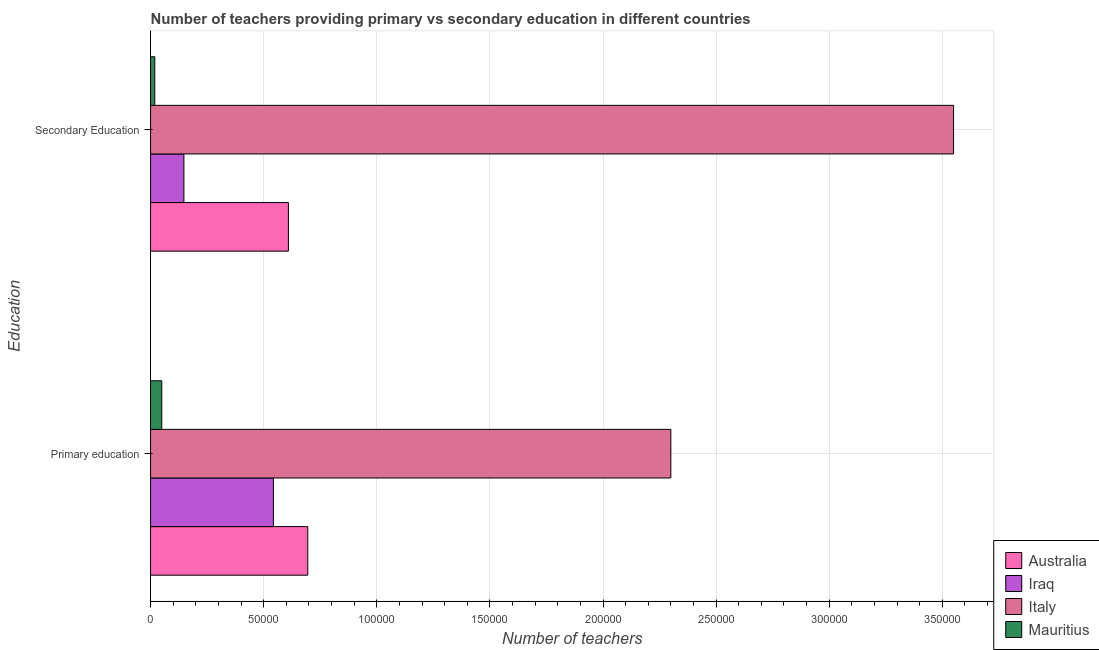How many different coloured bars are there?
Keep it short and to the point. 4. Are the number of bars per tick equal to the number of legend labels?
Your response must be concise. Yes. Are the number of bars on each tick of the Y-axis equal?
Offer a terse response. Yes. How many bars are there on the 2nd tick from the top?
Your answer should be compact. 4. How many bars are there on the 2nd tick from the bottom?
Your answer should be very brief. 4. What is the label of the 2nd group of bars from the top?
Offer a terse response. Primary education. What is the number of primary teachers in Australia?
Your answer should be compact. 6.95e+04. Across all countries, what is the maximum number of primary teachers?
Offer a very short reply. 2.30e+05. Across all countries, what is the minimum number of primary teachers?
Give a very brief answer. 4952. In which country was the number of primary teachers maximum?
Offer a very short reply. Italy. In which country was the number of secondary teachers minimum?
Offer a very short reply. Mauritius. What is the total number of secondary teachers in the graph?
Provide a short and direct response. 4.33e+05. What is the difference between the number of secondary teachers in Iraq and that in Italy?
Your response must be concise. -3.40e+05. What is the difference between the number of primary teachers in Australia and the number of secondary teachers in Italy?
Your answer should be compact. -2.85e+05. What is the average number of secondary teachers per country?
Make the answer very short. 1.08e+05. What is the difference between the number of primary teachers and number of secondary teachers in Italy?
Offer a very short reply. -1.25e+05. In how many countries, is the number of primary teachers greater than 280000 ?
Your response must be concise. 0. What is the ratio of the number of secondary teachers in Mauritius to that in Australia?
Provide a succinct answer. 0.03. Is the number of primary teachers in Italy less than that in Iraq?
Provide a short and direct response. No. How many bars are there?
Offer a very short reply. 8. Are all the bars in the graph horizontal?
Make the answer very short. Yes. How many countries are there in the graph?
Offer a terse response. 4. Are the values on the major ticks of X-axis written in scientific E-notation?
Provide a succinct answer. No. Does the graph contain any zero values?
Offer a terse response. No. Where does the legend appear in the graph?
Keep it short and to the point. Bottom right. How many legend labels are there?
Your answer should be compact. 4. How are the legend labels stacked?
Give a very brief answer. Vertical. What is the title of the graph?
Offer a terse response. Number of teachers providing primary vs secondary education in different countries. What is the label or title of the X-axis?
Provide a short and direct response. Number of teachers. What is the label or title of the Y-axis?
Provide a succinct answer. Education. What is the Number of teachers in Australia in Primary education?
Provide a short and direct response. 6.95e+04. What is the Number of teachers in Iraq in Primary education?
Your answer should be compact. 5.43e+04. What is the Number of teachers in Italy in Primary education?
Your answer should be compact. 2.30e+05. What is the Number of teachers in Mauritius in Primary education?
Provide a succinct answer. 4952. What is the Number of teachers in Australia in Secondary Education?
Provide a succinct answer. 6.09e+04. What is the Number of teachers in Iraq in Secondary Education?
Your response must be concise. 1.47e+04. What is the Number of teachers of Italy in Secondary Education?
Ensure brevity in your answer.  3.55e+05. What is the Number of teachers of Mauritius in Secondary Education?
Offer a terse response. 1856. Across all Education, what is the maximum Number of teachers of Australia?
Offer a very short reply. 6.95e+04. Across all Education, what is the maximum Number of teachers in Iraq?
Make the answer very short. 5.43e+04. Across all Education, what is the maximum Number of teachers of Italy?
Offer a terse response. 3.55e+05. Across all Education, what is the maximum Number of teachers of Mauritius?
Make the answer very short. 4952. Across all Education, what is the minimum Number of teachers in Australia?
Make the answer very short. 6.09e+04. Across all Education, what is the minimum Number of teachers of Iraq?
Your answer should be very brief. 1.47e+04. Across all Education, what is the minimum Number of teachers in Italy?
Offer a terse response. 2.30e+05. Across all Education, what is the minimum Number of teachers of Mauritius?
Provide a short and direct response. 1856. What is the total Number of teachers in Australia in the graph?
Your response must be concise. 1.30e+05. What is the total Number of teachers of Iraq in the graph?
Your response must be concise. 6.90e+04. What is the total Number of teachers of Italy in the graph?
Provide a succinct answer. 5.85e+05. What is the total Number of teachers of Mauritius in the graph?
Make the answer very short. 6808. What is the difference between the Number of teachers of Australia in Primary education and that in Secondary Education?
Give a very brief answer. 8561. What is the difference between the Number of teachers of Iraq in Primary education and that in Secondary Education?
Offer a terse response. 3.96e+04. What is the difference between the Number of teachers in Italy in Primary education and that in Secondary Education?
Provide a short and direct response. -1.25e+05. What is the difference between the Number of teachers in Mauritius in Primary education and that in Secondary Education?
Your answer should be very brief. 3096. What is the difference between the Number of teachers of Australia in Primary education and the Number of teachers of Iraq in Secondary Education?
Your response must be concise. 5.48e+04. What is the difference between the Number of teachers of Australia in Primary education and the Number of teachers of Italy in Secondary Education?
Offer a terse response. -2.85e+05. What is the difference between the Number of teachers of Australia in Primary education and the Number of teachers of Mauritius in Secondary Education?
Your answer should be very brief. 6.76e+04. What is the difference between the Number of teachers in Iraq in Primary education and the Number of teachers in Italy in Secondary Education?
Offer a terse response. -3.01e+05. What is the difference between the Number of teachers in Iraq in Primary education and the Number of teachers in Mauritius in Secondary Education?
Provide a succinct answer. 5.24e+04. What is the difference between the Number of teachers of Italy in Primary education and the Number of teachers of Mauritius in Secondary Education?
Make the answer very short. 2.28e+05. What is the average Number of teachers in Australia per Education?
Give a very brief answer. 6.52e+04. What is the average Number of teachers of Iraq per Education?
Your answer should be compact. 3.45e+04. What is the average Number of teachers of Italy per Education?
Provide a short and direct response. 2.92e+05. What is the average Number of teachers of Mauritius per Education?
Provide a succinct answer. 3404. What is the difference between the Number of teachers in Australia and Number of teachers in Iraq in Primary education?
Provide a succinct answer. 1.52e+04. What is the difference between the Number of teachers of Australia and Number of teachers of Italy in Primary education?
Ensure brevity in your answer.  -1.60e+05. What is the difference between the Number of teachers in Australia and Number of teachers in Mauritius in Primary education?
Offer a terse response. 6.45e+04. What is the difference between the Number of teachers in Iraq and Number of teachers in Italy in Primary education?
Provide a short and direct response. -1.76e+05. What is the difference between the Number of teachers of Iraq and Number of teachers of Mauritius in Primary education?
Keep it short and to the point. 4.94e+04. What is the difference between the Number of teachers in Italy and Number of teachers in Mauritius in Primary education?
Provide a succinct answer. 2.25e+05. What is the difference between the Number of teachers in Australia and Number of teachers in Iraq in Secondary Education?
Ensure brevity in your answer.  4.62e+04. What is the difference between the Number of teachers in Australia and Number of teachers in Italy in Secondary Education?
Your answer should be compact. -2.94e+05. What is the difference between the Number of teachers of Australia and Number of teachers of Mauritius in Secondary Education?
Your response must be concise. 5.91e+04. What is the difference between the Number of teachers of Iraq and Number of teachers of Italy in Secondary Education?
Make the answer very short. -3.40e+05. What is the difference between the Number of teachers of Iraq and Number of teachers of Mauritius in Secondary Education?
Offer a very short reply. 1.29e+04. What is the difference between the Number of teachers in Italy and Number of teachers in Mauritius in Secondary Education?
Your answer should be compact. 3.53e+05. What is the ratio of the Number of teachers in Australia in Primary education to that in Secondary Education?
Provide a short and direct response. 1.14. What is the ratio of the Number of teachers of Iraq in Primary education to that in Secondary Education?
Provide a short and direct response. 3.68. What is the ratio of the Number of teachers in Italy in Primary education to that in Secondary Education?
Your answer should be compact. 0.65. What is the ratio of the Number of teachers of Mauritius in Primary education to that in Secondary Education?
Keep it short and to the point. 2.67. What is the difference between the highest and the second highest Number of teachers in Australia?
Your answer should be compact. 8561. What is the difference between the highest and the second highest Number of teachers of Iraq?
Your answer should be very brief. 3.96e+04. What is the difference between the highest and the second highest Number of teachers in Italy?
Your answer should be compact. 1.25e+05. What is the difference between the highest and the second highest Number of teachers of Mauritius?
Give a very brief answer. 3096. What is the difference between the highest and the lowest Number of teachers of Australia?
Provide a succinct answer. 8561. What is the difference between the highest and the lowest Number of teachers of Iraq?
Your answer should be compact. 3.96e+04. What is the difference between the highest and the lowest Number of teachers in Italy?
Your answer should be very brief. 1.25e+05. What is the difference between the highest and the lowest Number of teachers of Mauritius?
Your response must be concise. 3096. 